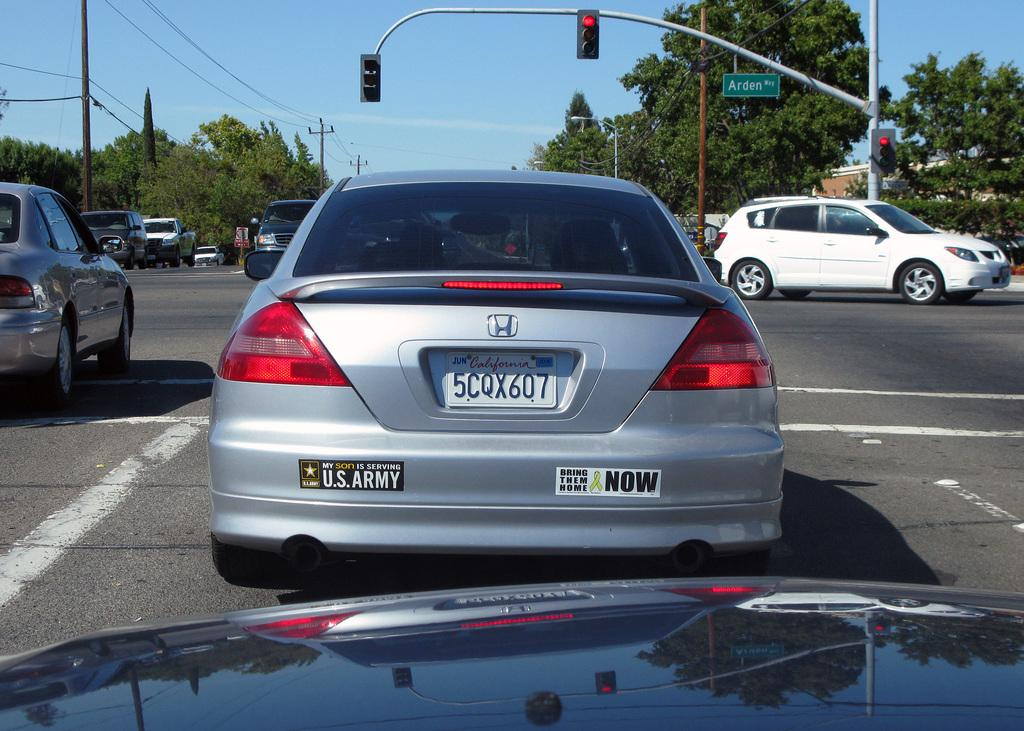What type of vehicles can be seen on the road in the image? There are cars on the road in the image. What can be seen in the background of the image? There are trees, poles, and wires in the background of the image. What type of waves can be seen crashing on the shore in the image? There are no waves or shore present in the image; it features cars on the road and trees, poles, and wires in the background. 